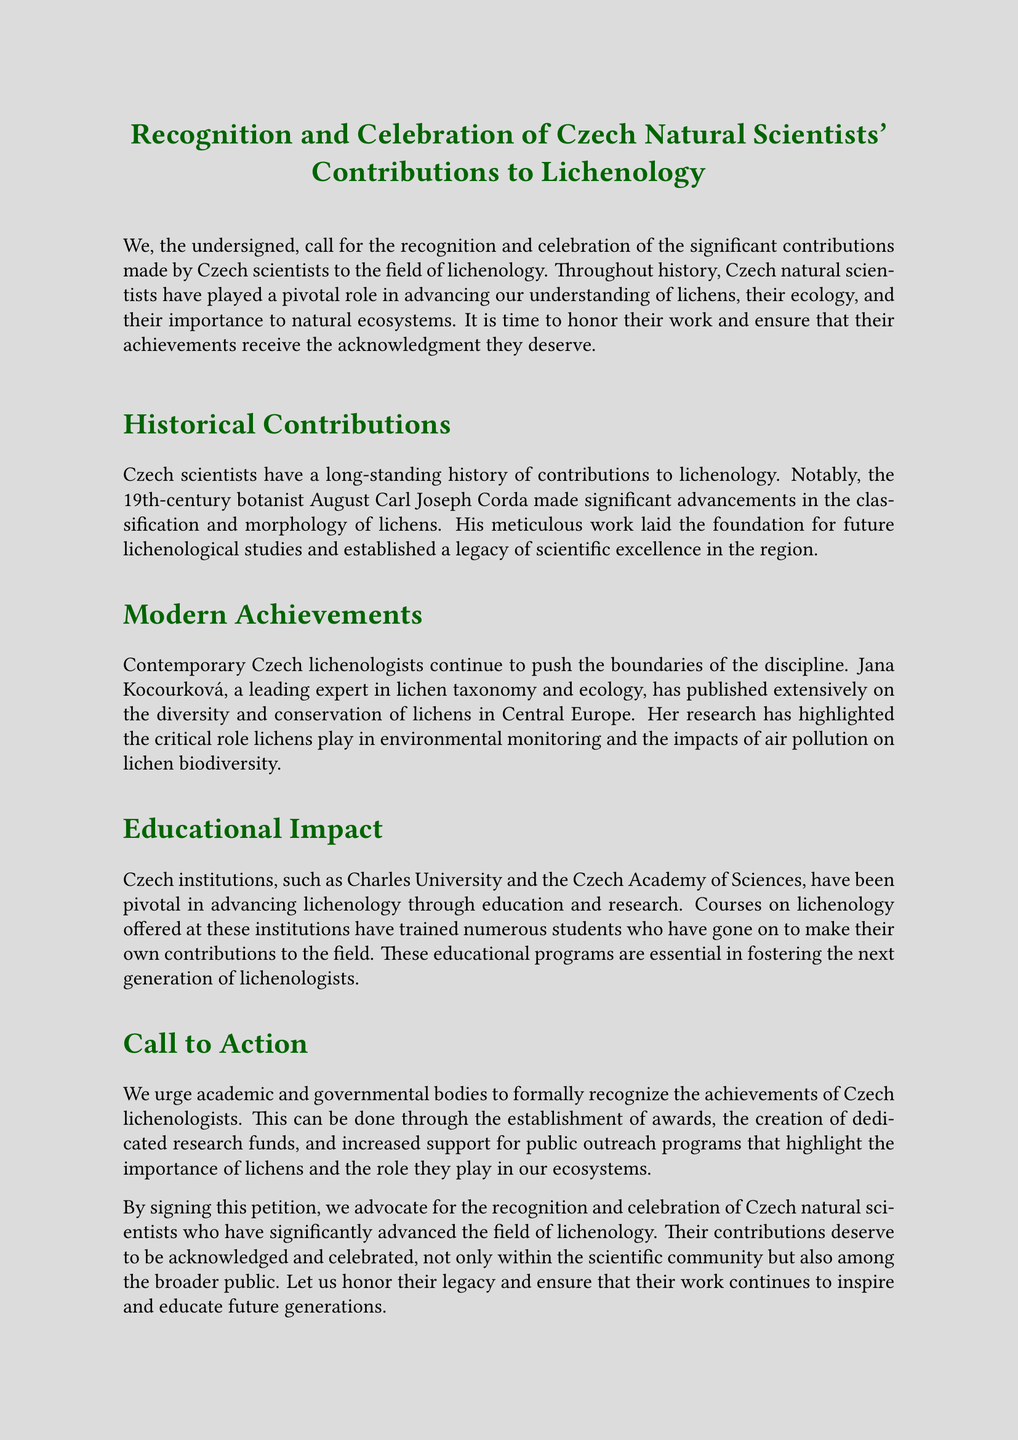What is the title of the petition? The title of the petition is prominently displayed at the beginning of the document.
Answer: Recognition and Celebration of Czech Natural Scientists' Contributions to Lichenology Who is mentioned as a notable 19th-century botanist? The document highlights significant individuals in the history of Czech lichenology.
Answer: August Carl Joseph Corda Which contemporary expert is mentioned in modern achievements? The petition outlines recent contributions made by Czech lichenologists.
Answer: Jana Kocourková What role do lichens play according to the petition? The petition discusses the ecological significance of lichens in the ecosystem.
Answer: Environmental monitoring What institutions are noted for their impact on education in lichenology? The petition highlights institutions that contribute to education and research in lichenology.
Answer: Charles University and the Czech Academy of Sciences What is the main call to action in the petition? The document includes a specific appeal directed to academic and governmental bodies.
Answer: Formal recognition of achievements How are signatories referred to in the document? The petition concludes with a description of the people who support the cause.
Answer: Lichen Enthusiasts and Supporters worldwide What kind of programs does the petition advocate for more support? The document specifies the types of initiatives that require increased attention.
Answer: Public outreach programs 